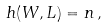Convert formula to latex. <formula><loc_0><loc_0><loc_500><loc_500>h ( W , L ) = n \, ,</formula> 